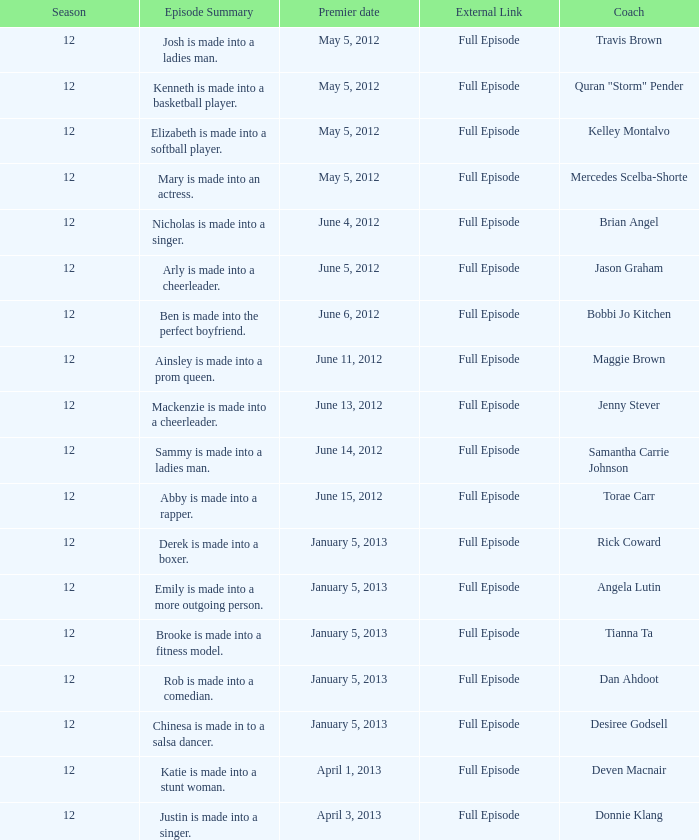Provide the episode outline for torae carr. Abby is made into a rapper. 